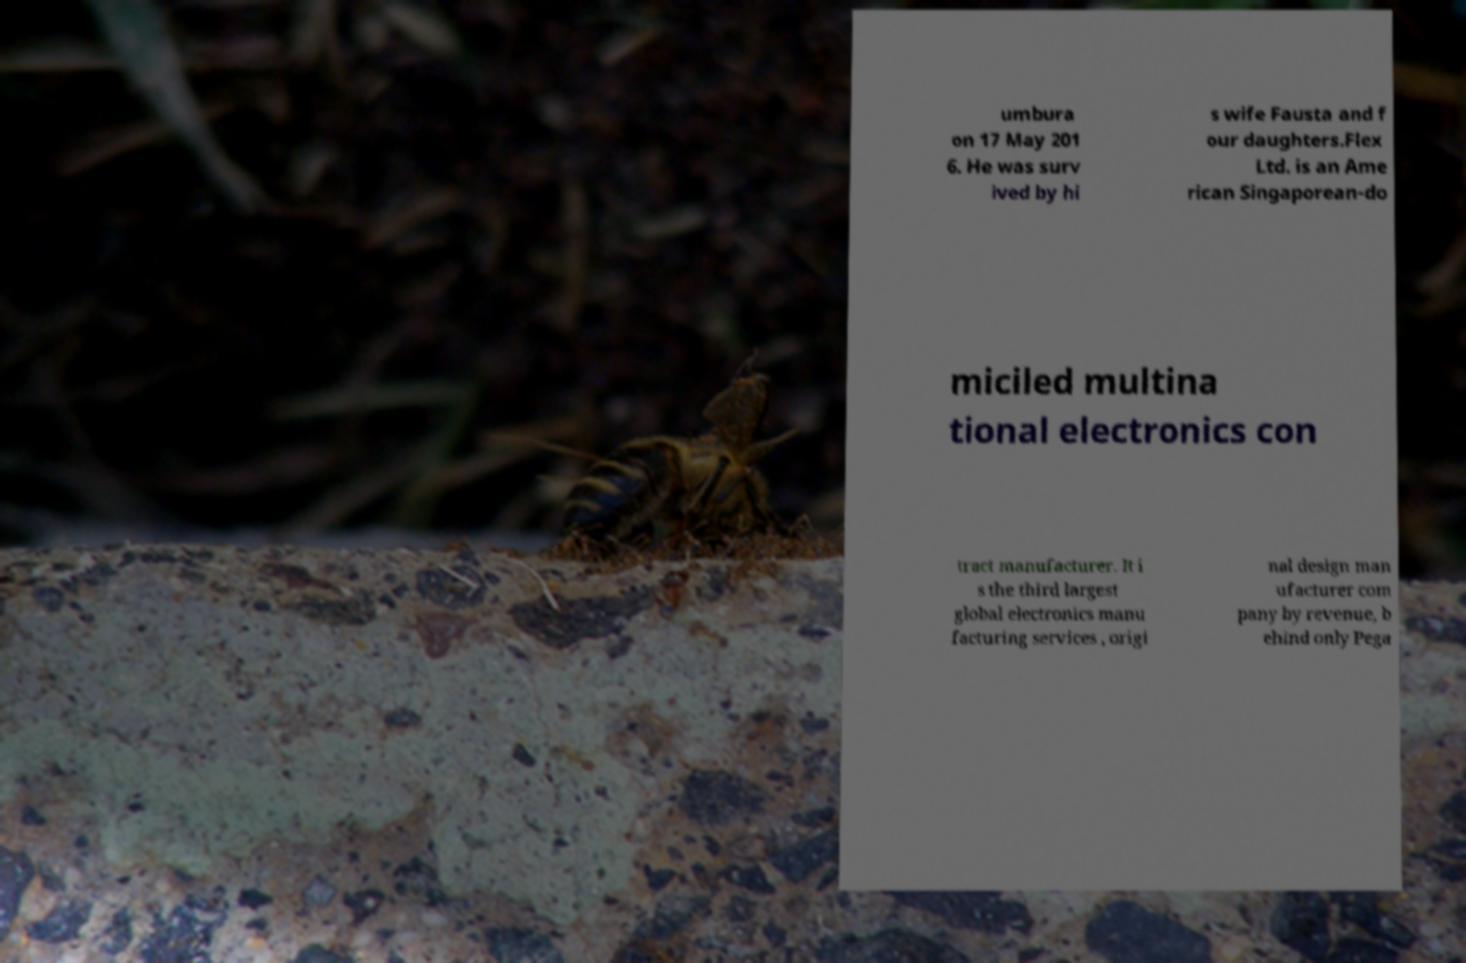For documentation purposes, I need the text within this image transcribed. Could you provide that? umbura on 17 May 201 6. He was surv ived by hi s wife Fausta and f our daughters.Flex Ltd. is an Ame rican Singaporean-do miciled multina tional electronics con tract manufacturer. It i s the third largest global electronics manu facturing services , origi nal design man ufacturer com pany by revenue, b ehind only Pega 